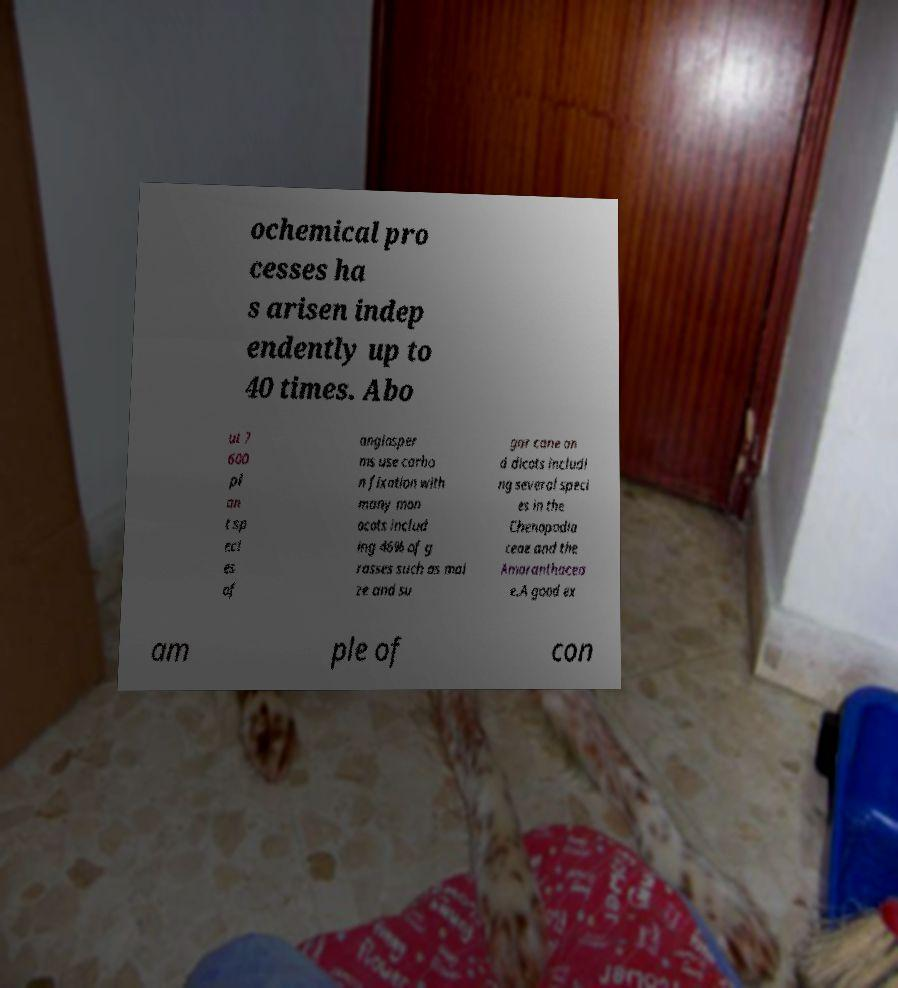For documentation purposes, I need the text within this image transcribed. Could you provide that? ochemical pro cesses ha s arisen indep endently up to 40 times. Abo ut 7 600 pl an t sp eci es of angiosper ms use carbo n fixation with many mon ocots includ ing 46% of g rasses such as mai ze and su gar cane an d dicots includi ng several speci es in the Chenopodia ceae and the Amaranthacea e.A good ex am ple of con 